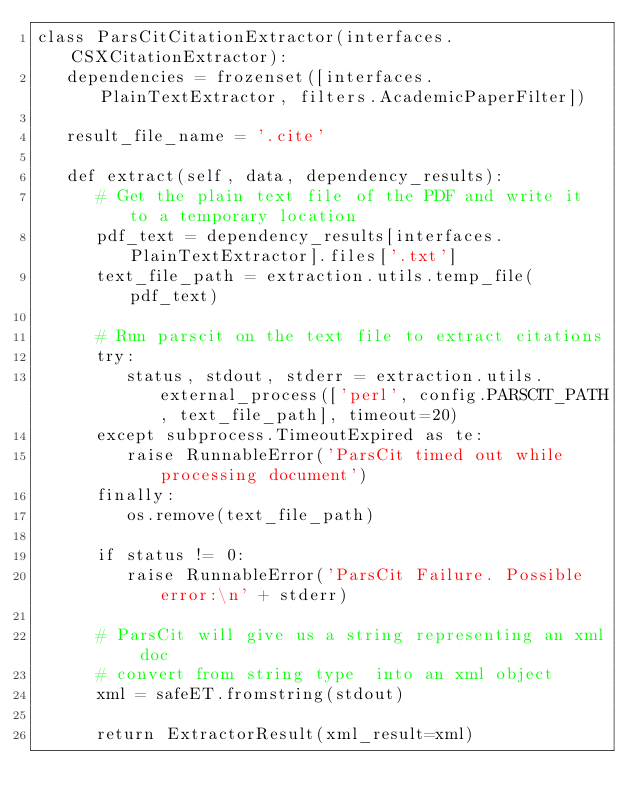<code> <loc_0><loc_0><loc_500><loc_500><_Python_>class ParsCitCitationExtractor(interfaces.CSXCitationExtractor):
   dependencies = frozenset([interfaces.PlainTextExtractor, filters.AcademicPaperFilter])

   result_file_name = '.cite'

   def extract(self, data, dependency_results):
      # Get the plain text file of the PDF and write it to a temporary location
      pdf_text = dependency_results[interfaces.PlainTextExtractor].files['.txt']
      text_file_path = extraction.utils.temp_file(pdf_text)

      # Run parscit on the text file to extract citations
      try:
         status, stdout, stderr = extraction.utils.external_process(['perl', config.PARSCIT_PATH, text_file_path], timeout=20)
      except subprocess.TimeoutExpired as te:
         raise RunnableError('ParsCit timed out while processing document')
      finally:
         os.remove(text_file_path)

      if status != 0:
         raise RunnableError('ParsCit Failure. Possible error:\n' + stderr)

      # ParsCit will give us a string representing an xml doc
      # convert from string type  into an xml object
      xml = safeET.fromstring(stdout)

      return ExtractorResult(xml_result=xml)


</code> 